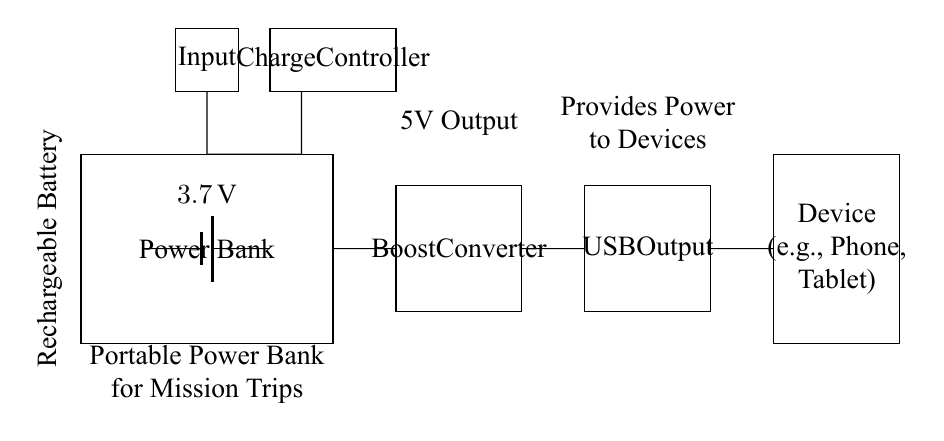What components are present in the circuit? The circuit contains a rechargeable battery, a boost converter, a charge controller, a USB output, and an input port. Each component is represented within the power bank rectangle, which supports charging devices.
Answer: five components What is the voltage of the battery? The circuit shows the battery labeled with a voltage of three point seven volts. This is the nominal voltage of the rechargeable battery used in the power bank.
Answer: three point seven volts How does the boost converter function in this circuit? The boost converter increases the voltage from the battery level (three point seven volts) to the standard USB output level (five volts), enabling the power bank to charge devices that require a higher voltage. This is essential for compatibility with most USB devices.
Answer: increases voltage What is the purpose of the charge controller? The charge controller regulates the charging process, ensuring that the battery charges safely and efficiently. It prevents overcharging and monitors the battery status, which is crucial for prolonging battery life, especially during mission trips.
Answer: regulates charging Which component provides power to external devices? The USB output component is specifically designed to connect to devices like phones or tablets, providing the necessary power for charging. The connection indicated at this output ensures that devices can be powered externally.
Answer: USB output What is the output voltage provided by the USB output? The USB output in this circuit is designed to provide a five-volt output, which is the standard voltage for USB-powered devices. This specification allows compatibility with a wide range of electronics.
Answer: five volts Why is a rechargeable battery used in this circuit? A rechargeable battery is essential for this power bank as it allows multiple uses during mission trips without needing to replace the battery. It enables the power bank to be reused after each charge cycle, making it practical and cost-effective for long-term usage.
Answer: multipurpose usage 